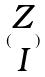<formula> <loc_0><loc_0><loc_500><loc_500>( \begin{matrix} Z \\ I \end{matrix} )</formula> 